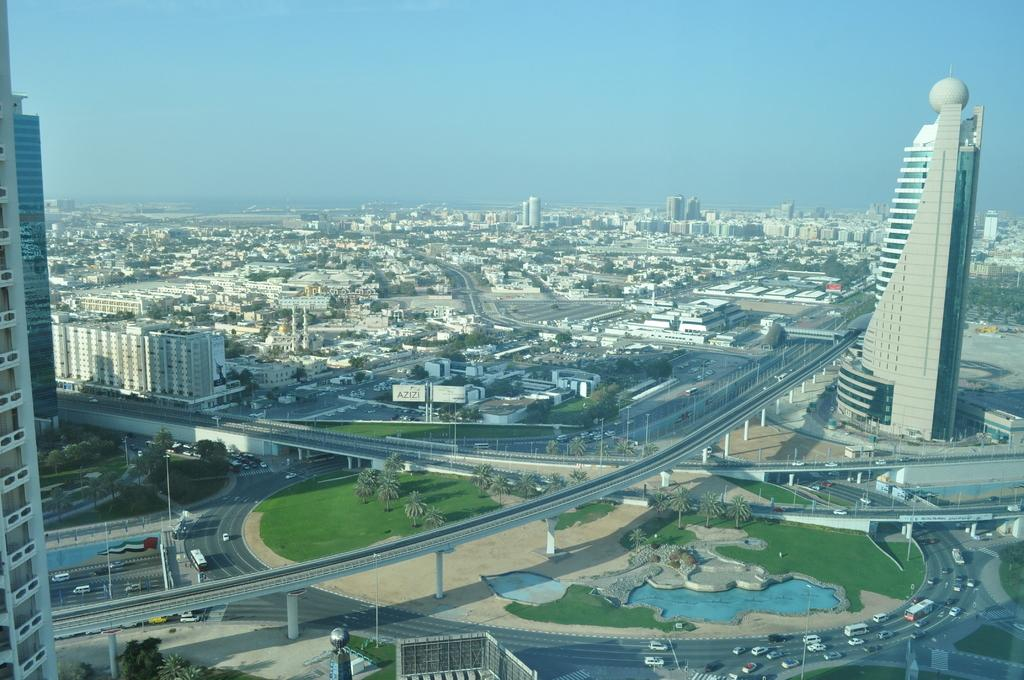What type of view is shown in the image? The image is an outside view. What can be seen on the road in the image? There are vehicles on the road in the image. What type of vegetation is present in the image? There are trees in the image. What type of area is depicted in the image? There is a garden in the image. What type of structures are visible in the image? There are buildings in the image. What type of architectural feature is present in the image? There is a bridge in the image. What is visible at the top of the image? The sky is visible at the top of the image. What type of coat is hanging on the tree in the image? There is no coat hanging on the tree in the image; only trees are present. What type of plants are growing on the ground in the image? The image does not show any plants growing on the ground; it only shows trees and a garden. 